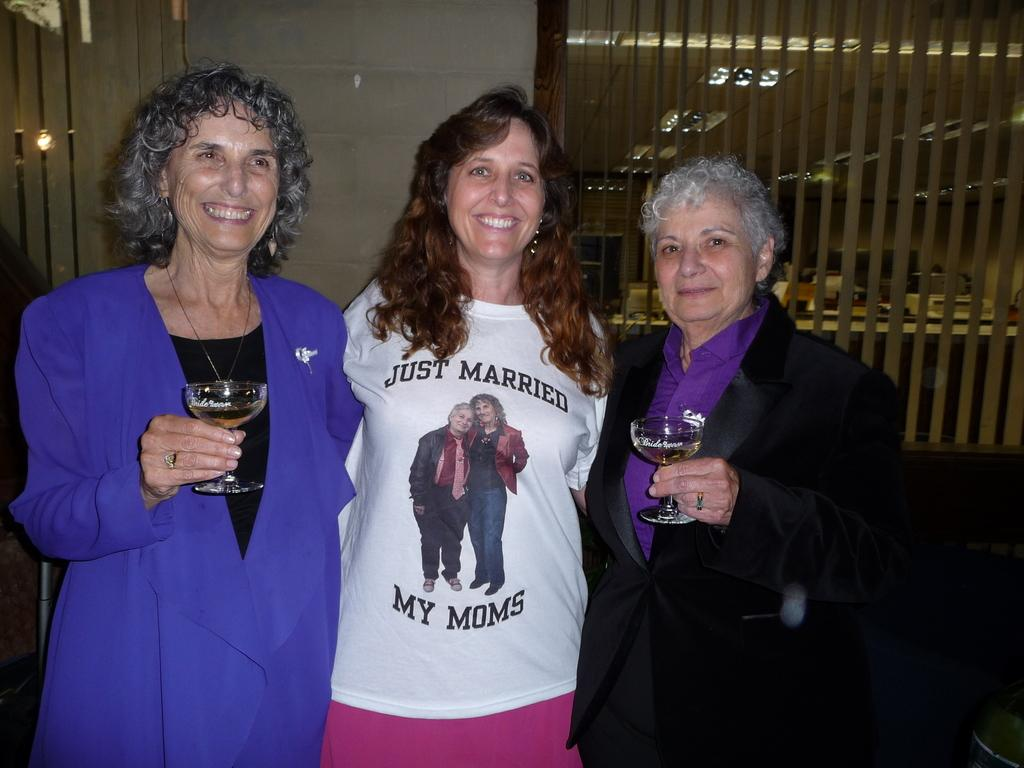What are the people in the image doing? The people in the image are standing and smiling. What are the people holding in their hands? The people are holding glasses in their hands. What is located behind the people in the image? There is a wall behind the people in the image. What is visible at the top of the image? The top of the image contains a roof. What can be seen providing illumination in the image? There are lights visible in the image. Reasoning: Let' Let's think step by step in order to produce the conversation. We start by identifying the main subjects in the image, which are the people. Then, we describe their actions and what they are holding. Next, we mention the background and the top of the image. Finally, we focus on the lighting in the image. Each question is designed to elicit a specific detail about the image that is known from the provided facts. Absurd Question/Answer: What type of wheel can be seen in the image? There is no wheel present in the image. Is there a guitar being played by any of the people in the image? No, there is no guitar visible in the image. 